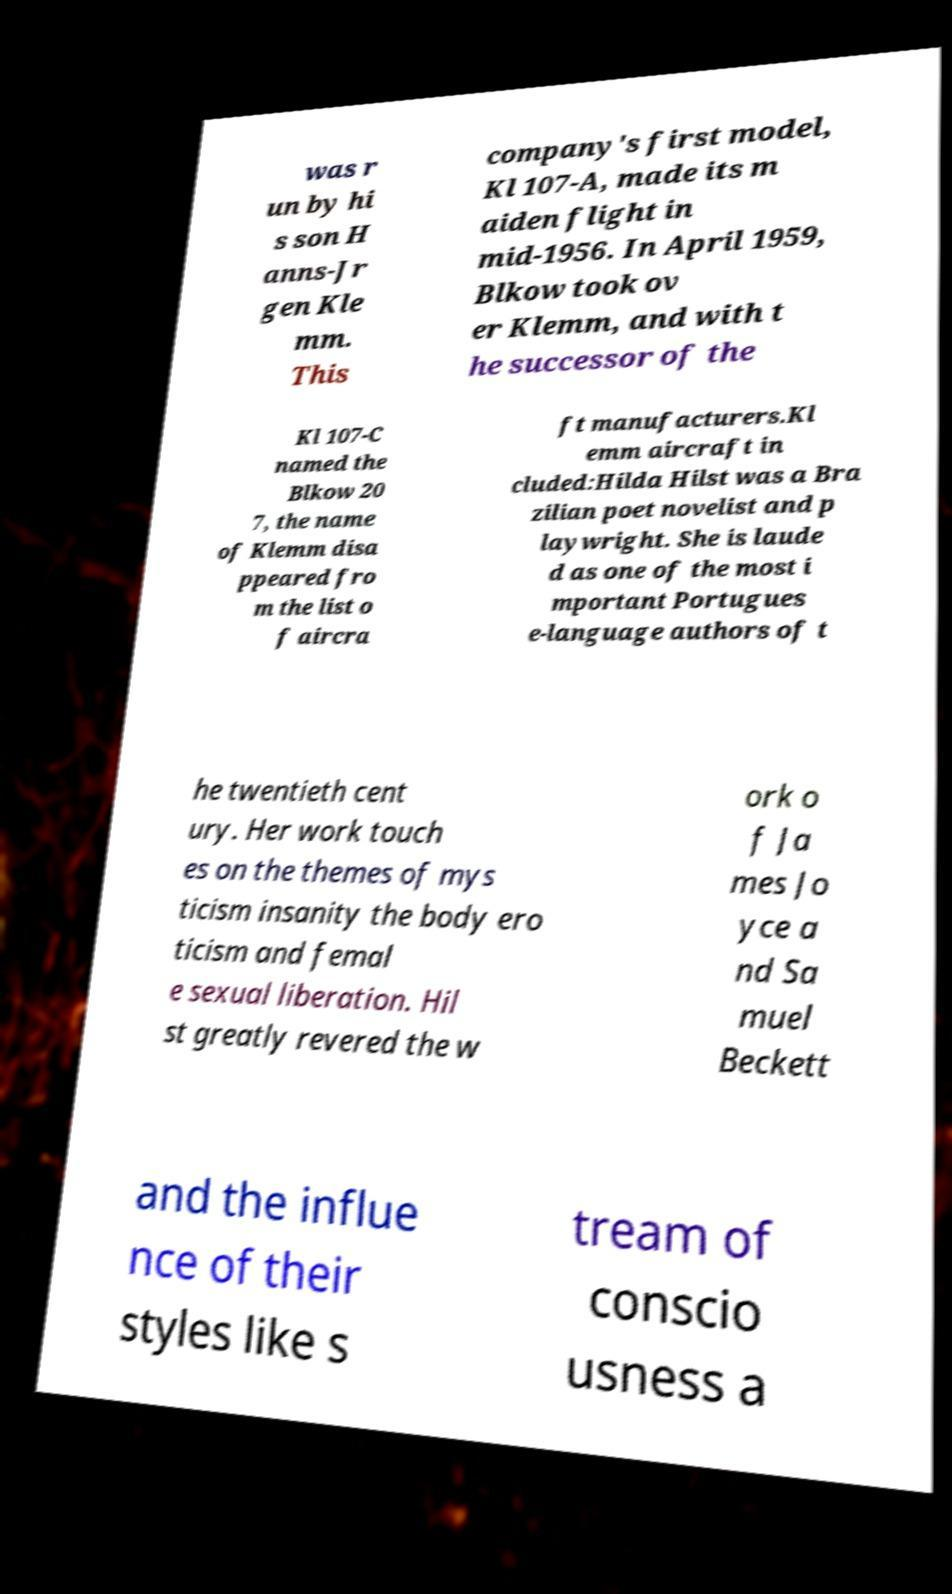Please identify and transcribe the text found in this image. was r un by hi s son H anns-Jr gen Kle mm. This company's first model, Kl 107-A, made its m aiden flight in mid-1956. In April 1959, Blkow took ov er Klemm, and with t he successor of the Kl 107-C named the Blkow 20 7, the name of Klemm disa ppeared fro m the list o f aircra ft manufacturers.Kl emm aircraft in cluded:Hilda Hilst was a Bra zilian poet novelist and p laywright. She is laude d as one of the most i mportant Portugues e-language authors of t he twentieth cent ury. Her work touch es on the themes of mys ticism insanity the body ero ticism and femal e sexual liberation. Hil st greatly revered the w ork o f Ja mes Jo yce a nd Sa muel Beckett and the influe nce of their styles like s tream of conscio usness a 